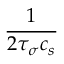Convert formula to latex. <formula><loc_0><loc_0><loc_500><loc_500>\frac { 1 } { 2 \tau _ { \sigma } c _ { s } }</formula> 